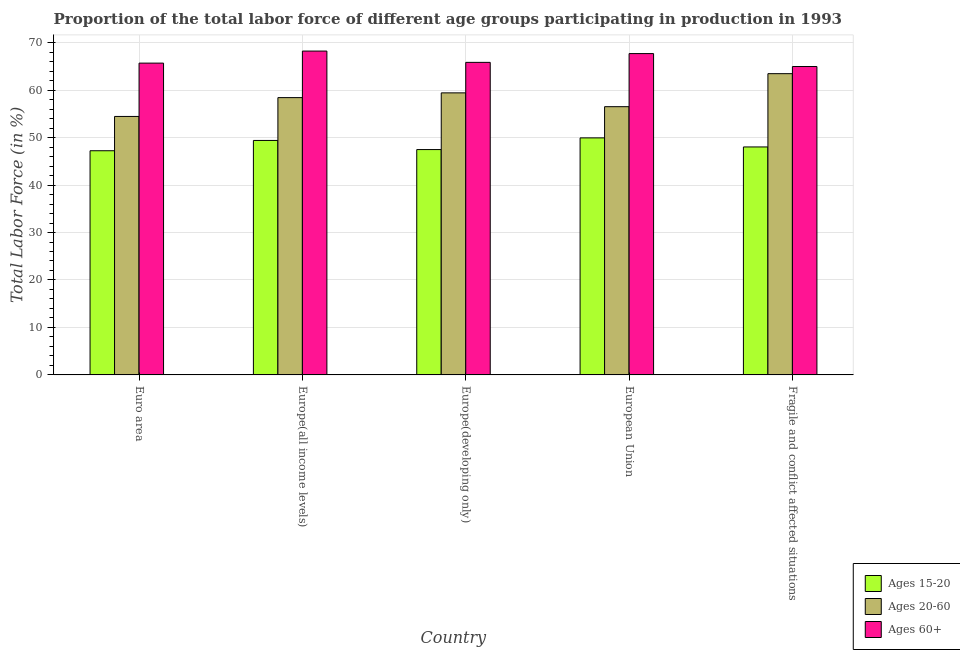How many different coloured bars are there?
Make the answer very short. 3. How many bars are there on the 4th tick from the right?
Ensure brevity in your answer.  3. What is the label of the 2nd group of bars from the left?
Your answer should be compact. Europe(all income levels). What is the percentage of labor force above age 60 in European Union?
Keep it short and to the point. 67.69. Across all countries, what is the maximum percentage of labor force within the age group 15-20?
Your response must be concise. 49.94. Across all countries, what is the minimum percentage of labor force within the age group 20-60?
Your answer should be compact. 54.45. In which country was the percentage of labor force within the age group 15-20 minimum?
Give a very brief answer. Euro area. What is the total percentage of labor force within the age group 15-20 in the graph?
Keep it short and to the point. 242.06. What is the difference between the percentage of labor force within the age group 20-60 in Europe(all income levels) and that in Europe(developing only)?
Offer a terse response. -1. What is the difference between the percentage of labor force above age 60 in Euro area and the percentage of labor force within the age group 15-20 in Europe(all income levels)?
Offer a terse response. 16.29. What is the average percentage of labor force within the age group 20-60 per country?
Give a very brief answer. 58.45. What is the difference between the percentage of labor force within the age group 15-20 and percentage of labor force within the age group 20-60 in Europe(developing only)?
Your answer should be very brief. -11.94. What is the ratio of the percentage of labor force above age 60 in European Union to that in Fragile and conflict affected situations?
Provide a succinct answer. 1.04. Is the percentage of labor force within the age group 20-60 in Europe(all income levels) less than that in Fragile and conflict affected situations?
Your answer should be very brief. Yes. What is the difference between the highest and the second highest percentage of labor force above age 60?
Keep it short and to the point. 0.53. What is the difference between the highest and the lowest percentage of labor force within the age group 20-60?
Offer a very short reply. 9.01. In how many countries, is the percentage of labor force within the age group 15-20 greater than the average percentage of labor force within the age group 15-20 taken over all countries?
Make the answer very short. 2. What does the 1st bar from the left in Euro area represents?
Provide a succinct answer. Ages 15-20. What does the 3rd bar from the right in Europe(developing only) represents?
Offer a terse response. Ages 15-20. Is it the case that in every country, the sum of the percentage of labor force within the age group 15-20 and percentage of labor force within the age group 20-60 is greater than the percentage of labor force above age 60?
Provide a short and direct response. Yes. Are all the bars in the graph horizontal?
Keep it short and to the point. No. How many legend labels are there?
Offer a very short reply. 3. What is the title of the graph?
Your response must be concise. Proportion of the total labor force of different age groups participating in production in 1993. What is the label or title of the Y-axis?
Provide a succinct answer. Total Labor Force (in %). What is the Total Labor Force (in %) of Ages 15-20 in Euro area?
Your answer should be very brief. 47.23. What is the Total Labor Force (in %) in Ages 20-60 in Euro area?
Offer a very short reply. 54.45. What is the Total Labor Force (in %) of Ages 60+ in Euro area?
Keep it short and to the point. 65.69. What is the Total Labor Force (in %) of Ages 15-20 in Europe(all income levels)?
Offer a terse response. 49.4. What is the Total Labor Force (in %) of Ages 20-60 in Europe(all income levels)?
Offer a very short reply. 58.42. What is the Total Labor Force (in %) of Ages 60+ in Europe(all income levels)?
Keep it short and to the point. 68.22. What is the Total Labor Force (in %) in Ages 15-20 in Europe(developing only)?
Keep it short and to the point. 47.47. What is the Total Labor Force (in %) of Ages 20-60 in Europe(developing only)?
Keep it short and to the point. 59.42. What is the Total Labor Force (in %) in Ages 60+ in Europe(developing only)?
Offer a terse response. 65.84. What is the Total Labor Force (in %) of Ages 15-20 in European Union?
Your answer should be compact. 49.94. What is the Total Labor Force (in %) of Ages 20-60 in European Union?
Provide a short and direct response. 56.51. What is the Total Labor Force (in %) in Ages 60+ in European Union?
Your answer should be compact. 67.69. What is the Total Labor Force (in %) of Ages 15-20 in Fragile and conflict affected situations?
Provide a short and direct response. 48.03. What is the Total Labor Force (in %) of Ages 20-60 in Fragile and conflict affected situations?
Keep it short and to the point. 63.46. What is the Total Labor Force (in %) in Ages 60+ in Fragile and conflict affected situations?
Offer a terse response. 64.97. Across all countries, what is the maximum Total Labor Force (in %) of Ages 15-20?
Give a very brief answer. 49.94. Across all countries, what is the maximum Total Labor Force (in %) of Ages 20-60?
Provide a succinct answer. 63.46. Across all countries, what is the maximum Total Labor Force (in %) in Ages 60+?
Your answer should be very brief. 68.22. Across all countries, what is the minimum Total Labor Force (in %) in Ages 15-20?
Keep it short and to the point. 47.23. Across all countries, what is the minimum Total Labor Force (in %) in Ages 20-60?
Give a very brief answer. 54.45. Across all countries, what is the minimum Total Labor Force (in %) in Ages 60+?
Provide a succinct answer. 64.97. What is the total Total Labor Force (in %) in Ages 15-20 in the graph?
Offer a terse response. 242.06. What is the total Total Labor Force (in %) of Ages 20-60 in the graph?
Your response must be concise. 292.26. What is the total Total Labor Force (in %) in Ages 60+ in the graph?
Offer a very short reply. 332.41. What is the difference between the Total Labor Force (in %) of Ages 15-20 in Euro area and that in Europe(all income levels)?
Provide a short and direct response. -2.17. What is the difference between the Total Labor Force (in %) of Ages 20-60 in Euro area and that in Europe(all income levels)?
Your answer should be compact. -3.96. What is the difference between the Total Labor Force (in %) of Ages 60+ in Euro area and that in Europe(all income levels)?
Provide a short and direct response. -2.54. What is the difference between the Total Labor Force (in %) of Ages 15-20 in Euro area and that in Europe(developing only)?
Your answer should be compact. -0.25. What is the difference between the Total Labor Force (in %) of Ages 20-60 in Euro area and that in Europe(developing only)?
Make the answer very short. -4.96. What is the difference between the Total Labor Force (in %) of Ages 60+ in Euro area and that in Europe(developing only)?
Provide a short and direct response. -0.16. What is the difference between the Total Labor Force (in %) in Ages 15-20 in Euro area and that in European Union?
Offer a very short reply. -2.71. What is the difference between the Total Labor Force (in %) of Ages 20-60 in Euro area and that in European Union?
Offer a very short reply. -2.06. What is the difference between the Total Labor Force (in %) in Ages 60+ in Euro area and that in European Union?
Offer a very short reply. -2.01. What is the difference between the Total Labor Force (in %) of Ages 15-20 in Euro area and that in Fragile and conflict affected situations?
Provide a succinct answer. -0.8. What is the difference between the Total Labor Force (in %) of Ages 20-60 in Euro area and that in Fragile and conflict affected situations?
Give a very brief answer. -9.01. What is the difference between the Total Labor Force (in %) in Ages 60+ in Euro area and that in Fragile and conflict affected situations?
Your response must be concise. 0.72. What is the difference between the Total Labor Force (in %) in Ages 15-20 in Europe(all income levels) and that in Europe(developing only)?
Offer a very short reply. 1.92. What is the difference between the Total Labor Force (in %) of Ages 20-60 in Europe(all income levels) and that in Europe(developing only)?
Your answer should be compact. -1. What is the difference between the Total Labor Force (in %) of Ages 60+ in Europe(all income levels) and that in Europe(developing only)?
Make the answer very short. 2.38. What is the difference between the Total Labor Force (in %) in Ages 15-20 in Europe(all income levels) and that in European Union?
Ensure brevity in your answer.  -0.54. What is the difference between the Total Labor Force (in %) in Ages 20-60 in Europe(all income levels) and that in European Union?
Provide a short and direct response. 1.91. What is the difference between the Total Labor Force (in %) of Ages 60+ in Europe(all income levels) and that in European Union?
Your answer should be very brief. 0.53. What is the difference between the Total Labor Force (in %) in Ages 15-20 in Europe(all income levels) and that in Fragile and conflict affected situations?
Give a very brief answer. 1.37. What is the difference between the Total Labor Force (in %) of Ages 20-60 in Europe(all income levels) and that in Fragile and conflict affected situations?
Make the answer very short. -5.05. What is the difference between the Total Labor Force (in %) of Ages 60+ in Europe(all income levels) and that in Fragile and conflict affected situations?
Offer a very short reply. 3.26. What is the difference between the Total Labor Force (in %) of Ages 15-20 in Europe(developing only) and that in European Union?
Provide a short and direct response. -2.46. What is the difference between the Total Labor Force (in %) of Ages 20-60 in Europe(developing only) and that in European Union?
Offer a terse response. 2.91. What is the difference between the Total Labor Force (in %) of Ages 60+ in Europe(developing only) and that in European Union?
Ensure brevity in your answer.  -1.85. What is the difference between the Total Labor Force (in %) in Ages 15-20 in Europe(developing only) and that in Fragile and conflict affected situations?
Provide a succinct answer. -0.55. What is the difference between the Total Labor Force (in %) in Ages 20-60 in Europe(developing only) and that in Fragile and conflict affected situations?
Provide a succinct answer. -4.05. What is the difference between the Total Labor Force (in %) in Ages 60+ in Europe(developing only) and that in Fragile and conflict affected situations?
Offer a very short reply. 0.87. What is the difference between the Total Labor Force (in %) of Ages 15-20 in European Union and that in Fragile and conflict affected situations?
Ensure brevity in your answer.  1.91. What is the difference between the Total Labor Force (in %) in Ages 20-60 in European Union and that in Fragile and conflict affected situations?
Make the answer very short. -6.95. What is the difference between the Total Labor Force (in %) of Ages 60+ in European Union and that in Fragile and conflict affected situations?
Offer a terse response. 2.72. What is the difference between the Total Labor Force (in %) of Ages 15-20 in Euro area and the Total Labor Force (in %) of Ages 20-60 in Europe(all income levels)?
Make the answer very short. -11.19. What is the difference between the Total Labor Force (in %) of Ages 15-20 in Euro area and the Total Labor Force (in %) of Ages 60+ in Europe(all income levels)?
Offer a terse response. -21. What is the difference between the Total Labor Force (in %) of Ages 20-60 in Euro area and the Total Labor Force (in %) of Ages 60+ in Europe(all income levels)?
Provide a succinct answer. -13.77. What is the difference between the Total Labor Force (in %) in Ages 15-20 in Euro area and the Total Labor Force (in %) in Ages 20-60 in Europe(developing only)?
Give a very brief answer. -12.19. What is the difference between the Total Labor Force (in %) in Ages 15-20 in Euro area and the Total Labor Force (in %) in Ages 60+ in Europe(developing only)?
Offer a terse response. -18.62. What is the difference between the Total Labor Force (in %) in Ages 20-60 in Euro area and the Total Labor Force (in %) in Ages 60+ in Europe(developing only)?
Your answer should be very brief. -11.39. What is the difference between the Total Labor Force (in %) of Ages 15-20 in Euro area and the Total Labor Force (in %) of Ages 20-60 in European Union?
Provide a short and direct response. -9.28. What is the difference between the Total Labor Force (in %) in Ages 15-20 in Euro area and the Total Labor Force (in %) in Ages 60+ in European Union?
Provide a short and direct response. -20.47. What is the difference between the Total Labor Force (in %) in Ages 20-60 in Euro area and the Total Labor Force (in %) in Ages 60+ in European Union?
Your answer should be very brief. -13.24. What is the difference between the Total Labor Force (in %) in Ages 15-20 in Euro area and the Total Labor Force (in %) in Ages 20-60 in Fragile and conflict affected situations?
Keep it short and to the point. -16.24. What is the difference between the Total Labor Force (in %) in Ages 15-20 in Euro area and the Total Labor Force (in %) in Ages 60+ in Fragile and conflict affected situations?
Provide a short and direct response. -17.74. What is the difference between the Total Labor Force (in %) of Ages 20-60 in Euro area and the Total Labor Force (in %) of Ages 60+ in Fragile and conflict affected situations?
Ensure brevity in your answer.  -10.52. What is the difference between the Total Labor Force (in %) in Ages 15-20 in Europe(all income levels) and the Total Labor Force (in %) in Ages 20-60 in Europe(developing only)?
Make the answer very short. -10.02. What is the difference between the Total Labor Force (in %) of Ages 15-20 in Europe(all income levels) and the Total Labor Force (in %) of Ages 60+ in Europe(developing only)?
Your answer should be compact. -16.45. What is the difference between the Total Labor Force (in %) of Ages 20-60 in Europe(all income levels) and the Total Labor Force (in %) of Ages 60+ in Europe(developing only)?
Offer a very short reply. -7.43. What is the difference between the Total Labor Force (in %) in Ages 15-20 in Europe(all income levels) and the Total Labor Force (in %) in Ages 20-60 in European Union?
Offer a very short reply. -7.11. What is the difference between the Total Labor Force (in %) of Ages 15-20 in Europe(all income levels) and the Total Labor Force (in %) of Ages 60+ in European Union?
Your response must be concise. -18.3. What is the difference between the Total Labor Force (in %) in Ages 20-60 in Europe(all income levels) and the Total Labor Force (in %) in Ages 60+ in European Union?
Offer a very short reply. -9.28. What is the difference between the Total Labor Force (in %) of Ages 15-20 in Europe(all income levels) and the Total Labor Force (in %) of Ages 20-60 in Fragile and conflict affected situations?
Give a very brief answer. -14.07. What is the difference between the Total Labor Force (in %) of Ages 15-20 in Europe(all income levels) and the Total Labor Force (in %) of Ages 60+ in Fragile and conflict affected situations?
Offer a very short reply. -15.57. What is the difference between the Total Labor Force (in %) in Ages 20-60 in Europe(all income levels) and the Total Labor Force (in %) in Ages 60+ in Fragile and conflict affected situations?
Offer a very short reply. -6.55. What is the difference between the Total Labor Force (in %) in Ages 15-20 in Europe(developing only) and the Total Labor Force (in %) in Ages 20-60 in European Union?
Your answer should be very brief. -9.04. What is the difference between the Total Labor Force (in %) of Ages 15-20 in Europe(developing only) and the Total Labor Force (in %) of Ages 60+ in European Union?
Your response must be concise. -20.22. What is the difference between the Total Labor Force (in %) in Ages 20-60 in Europe(developing only) and the Total Labor Force (in %) in Ages 60+ in European Union?
Your answer should be compact. -8.28. What is the difference between the Total Labor Force (in %) in Ages 15-20 in Europe(developing only) and the Total Labor Force (in %) in Ages 20-60 in Fragile and conflict affected situations?
Your answer should be compact. -15.99. What is the difference between the Total Labor Force (in %) of Ages 15-20 in Europe(developing only) and the Total Labor Force (in %) of Ages 60+ in Fragile and conflict affected situations?
Make the answer very short. -17.5. What is the difference between the Total Labor Force (in %) of Ages 20-60 in Europe(developing only) and the Total Labor Force (in %) of Ages 60+ in Fragile and conflict affected situations?
Offer a terse response. -5.55. What is the difference between the Total Labor Force (in %) of Ages 15-20 in European Union and the Total Labor Force (in %) of Ages 20-60 in Fragile and conflict affected situations?
Provide a succinct answer. -13.53. What is the difference between the Total Labor Force (in %) in Ages 15-20 in European Union and the Total Labor Force (in %) in Ages 60+ in Fragile and conflict affected situations?
Keep it short and to the point. -15.03. What is the difference between the Total Labor Force (in %) in Ages 20-60 in European Union and the Total Labor Force (in %) in Ages 60+ in Fragile and conflict affected situations?
Your answer should be very brief. -8.46. What is the average Total Labor Force (in %) in Ages 15-20 per country?
Your answer should be very brief. 48.41. What is the average Total Labor Force (in %) of Ages 20-60 per country?
Ensure brevity in your answer.  58.45. What is the average Total Labor Force (in %) of Ages 60+ per country?
Provide a short and direct response. 66.48. What is the difference between the Total Labor Force (in %) of Ages 15-20 and Total Labor Force (in %) of Ages 20-60 in Euro area?
Keep it short and to the point. -7.23. What is the difference between the Total Labor Force (in %) in Ages 15-20 and Total Labor Force (in %) in Ages 60+ in Euro area?
Make the answer very short. -18.46. What is the difference between the Total Labor Force (in %) in Ages 20-60 and Total Labor Force (in %) in Ages 60+ in Euro area?
Make the answer very short. -11.23. What is the difference between the Total Labor Force (in %) in Ages 15-20 and Total Labor Force (in %) in Ages 20-60 in Europe(all income levels)?
Keep it short and to the point. -9.02. What is the difference between the Total Labor Force (in %) in Ages 15-20 and Total Labor Force (in %) in Ages 60+ in Europe(all income levels)?
Your response must be concise. -18.83. What is the difference between the Total Labor Force (in %) in Ages 20-60 and Total Labor Force (in %) in Ages 60+ in Europe(all income levels)?
Give a very brief answer. -9.81. What is the difference between the Total Labor Force (in %) of Ages 15-20 and Total Labor Force (in %) of Ages 20-60 in Europe(developing only)?
Make the answer very short. -11.94. What is the difference between the Total Labor Force (in %) of Ages 15-20 and Total Labor Force (in %) of Ages 60+ in Europe(developing only)?
Offer a very short reply. -18.37. What is the difference between the Total Labor Force (in %) of Ages 20-60 and Total Labor Force (in %) of Ages 60+ in Europe(developing only)?
Your response must be concise. -6.43. What is the difference between the Total Labor Force (in %) of Ages 15-20 and Total Labor Force (in %) of Ages 20-60 in European Union?
Your answer should be compact. -6.57. What is the difference between the Total Labor Force (in %) in Ages 15-20 and Total Labor Force (in %) in Ages 60+ in European Union?
Provide a succinct answer. -17.76. What is the difference between the Total Labor Force (in %) of Ages 20-60 and Total Labor Force (in %) of Ages 60+ in European Union?
Your answer should be compact. -11.18. What is the difference between the Total Labor Force (in %) of Ages 15-20 and Total Labor Force (in %) of Ages 20-60 in Fragile and conflict affected situations?
Your response must be concise. -15.44. What is the difference between the Total Labor Force (in %) in Ages 15-20 and Total Labor Force (in %) in Ages 60+ in Fragile and conflict affected situations?
Keep it short and to the point. -16.94. What is the difference between the Total Labor Force (in %) of Ages 20-60 and Total Labor Force (in %) of Ages 60+ in Fragile and conflict affected situations?
Give a very brief answer. -1.51. What is the ratio of the Total Labor Force (in %) of Ages 15-20 in Euro area to that in Europe(all income levels)?
Make the answer very short. 0.96. What is the ratio of the Total Labor Force (in %) in Ages 20-60 in Euro area to that in Europe(all income levels)?
Keep it short and to the point. 0.93. What is the ratio of the Total Labor Force (in %) in Ages 60+ in Euro area to that in Europe(all income levels)?
Your response must be concise. 0.96. What is the ratio of the Total Labor Force (in %) in Ages 20-60 in Euro area to that in Europe(developing only)?
Your answer should be compact. 0.92. What is the ratio of the Total Labor Force (in %) in Ages 60+ in Euro area to that in Europe(developing only)?
Ensure brevity in your answer.  1. What is the ratio of the Total Labor Force (in %) of Ages 15-20 in Euro area to that in European Union?
Offer a very short reply. 0.95. What is the ratio of the Total Labor Force (in %) in Ages 20-60 in Euro area to that in European Union?
Give a very brief answer. 0.96. What is the ratio of the Total Labor Force (in %) of Ages 60+ in Euro area to that in European Union?
Your answer should be very brief. 0.97. What is the ratio of the Total Labor Force (in %) in Ages 15-20 in Euro area to that in Fragile and conflict affected situations?
Your answer should be very brief. 0.98. What is the ratio of the Total Labor Force (in %) in Ages 20-60 in Euro area to that in Fragile and conflict affected situations?
Your answer should be very brief. 0.86. What is the ratio of the Total Labor Force (in %) in Ages 60+ in Euro area to that in Fragile and conflict affected situations?
Offer a terse response. 1.01. What is the ratio of the Total Labor Force (in %) of Ages 15-20 in Europe(all income levels) to that in Europe(developing only)?
Offer a terse response. 1.04. What is the ratio of the Total Labor Force (in %) in Ages 20-60 in Europe(all income levels) to that in Europe(developing only)?
Ensure brevity in your answer.  0.98. What is the ratio of the Total Labor Force (in %) in Ages 60+ in Europe(all income levels) to that in Europe(developing only)?
Provide a succinct answer. 1.04. What is the ratio of the Total Labor Force (in %) in Ages 15-20 in Europe(all income levels) to that in European Union?
Your answer should be compact. 0.99. What is the ratio of the Total Labor Force (in %) in Ages 20-60 in Europe(all income levels) to that in European Union?
Provide a short and direct response. 1.03. What is the ratio of the Total Labor Force (in %) of Ages 60+ in Europe(all income levels) to that in European Union?
Offer a terse response. 1.01. What is the ratio of the Total Labor Force (in %) in Ages 15-20 in Europe(all income levels) to that in Fragile and conflict affected situations?
Give a very brief answer. 1.03. What is the ratio of the Total Labor Force (in %) in Ages 20-60 in Europe(all income levels) to that in Fragile and conflict affected situations?
Your answer should be very brief. 0.92. What is the ratio of the Total Labor Force (in %) in Ages 60+ in Europe(all income levels) to that in Fragile and conflict affected situations?
Your answer should be compact. 1.05. What is the ratio of the Total Labor Force (in %) in Ages 15-20 in Europe(developing only) to that in European Union?
Offer a terse response. 0.95. What is the ratio of the Total Labor Force (in %) of Ages 20-60 in Europe(developing only) to that in European Union?
Your response must be concise. 1.05. What is the ratio of the Total Labor Force (in %) in Ages 60+ in Europe(developing only) to that in European Union?
Your response must be concise. 0.97. What is the ratio of the Total Labor Force (in %) in Ages 20-60 in Europe(developing only) to that in Fragile and conflict affected situations?
Provide a succinct answer. 0.94. What is the ratio of the Total Labor Force (in %) in Ages 60+ in Europe(developing only) to that in Fragile and conflict affected situations?
Provide a succinct answer. 1.01. What is the ratio of the Total Labor Force (in %) in Ages 15-20 in European Union to that in Fragile and conflict affected situations?
Your answer should be compact. 1.04. What is the ratio of the Total Labor Force (in %) of Ages 20-60 in European Union to that in Fragile and conflict affected situations?
Offer a very short reply. 0.89. What is the ratio of the Total Labor Force (in %) of Ages 60+ in European Union to that in Fragile and conflict affected situations?
Your answer should be very brief. 1.04. What is the difference between the highest and the second highest Total Labor Force (in %) in Ages 15-20?
Offer a very short reply. 0.54. What is the difference between the highest and the second highest Total Labor Force (in %) of Ages 20-60?
Provide a succinct answer. 4.05. What is the difference between the highest and the second highest Total Labor Force (in %) of Ages 60+?
Provide a succinct answer. 0.53. What is the difference between the highest and the lowest Total Labor Force (in %) of Ages 15-20?
Your answer should be compact. 2.71. What is the difference between the highest and the lowest Total Labor Force (in %) in Ages 20-60?
Provide a short and direct response. 9.01. What is the difference between the highest and the lowest Total Labor Force (in %) in Ages 60+?
Your response must be concise. 3.26. 